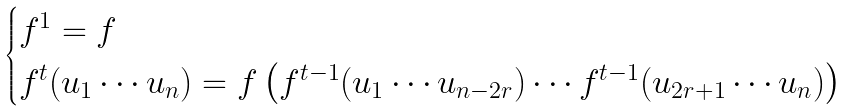Convert formula to latex. <formula><loc_0><loc_0><loc_500><loc_500>\begin{cases} f ^ { 1 } = f \\ f ^ { t } ( u _ { 1 } \cdots u _ { n } ) = f \left ( f ^ { t - 1 } ( u _ { 1 } \cdots u _ { n - 2 r } ) \cdots f ^ { t - 1 } ( u _ { 2 r + 1 } \cdots u _ { n } ) \right ) \end{cases}</formula> 